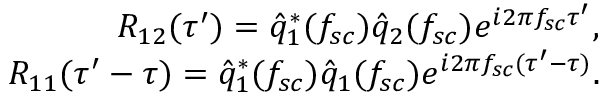<formula> <loc_0><loc_0><loc_500><loc_500>\begin{array} { r } { R _ { 1 2 } ( \tau ^ { \prime } ) = \hat { q } _ { 1 } ^ { * } ( f _ { s c } ) \hat { q } _ { 2 } ( f _ { s c } ) e ^ { i 2 \pi f _ { s c } \tau ^ { \prime } } , } \\ { R _ { 1 1 } ( \tau ^ { \prime } - \tau ) = \hat { q } _ { 1 } ^ { * } ( f _ { s c } ) \hat { q } _ { 1 } ( f _ { s c } ) e ^ { i 2 \pi f _ { s c } ( \tau ^ { \prime } - \tau ) } . } \end{array}</formula> 